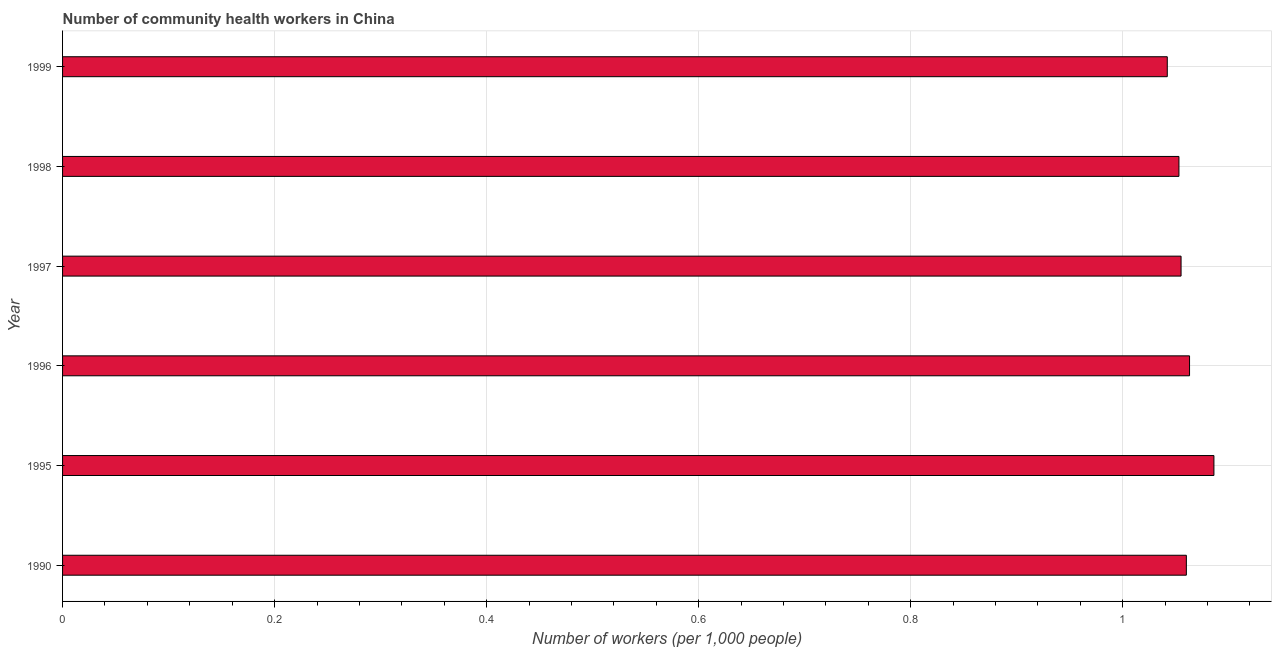Does the graph contain grids?
Your answer should be very brief. Yes. What is the title of the graph?
Your answer should be compact. Number of community health workers in China. What is the label or title of the X-axis?
Provide a succinct answer. Number of workers (per 1,0 people). What is the number of community health workers in 1998?
Provide a short and direct response. 1.05. Across all years, what is the maximum number of community health workers?
Provide a short and direct response. 1.09. Across all years, what is the minimum number of community health workers?
Ensure brevity in your answer.  1.04. In which year was the number of community health workers maximum?
Offer a terse response. 1995. What is the sum of the number of community health workers?
Provide a short and direct response. 6.36. What is the difference between the number of community health workers in 1990 and 1995?
Offer a terse response. -0.03. What is the average number of community health workers per year?
Offer a very short reply. 1.06. What is the median number of community health workers?
Provide a short and direct response. 1.06. Do a majority of the years between 1995 and 1997 (inclusive) have number of community health workers greater than 0.64 ?
Give a very brief answer. Yes. What is the difference between the highest and the second highest number of community health workers?
Provide a short and direct response. 0.02. What is the difference between the highest and the lowest number of community health workers?
Your answer should be compact. 0.04. How many bars are there?
Make the answer very short. 6. Are all the bars in the graph horizontal?
Make the answer very short. Yes. How many years are there in the graph?
Make the answer very short. 6. What is the difference between two consecutive major ticks on the X-axis?
Your answer should be very brief. 0.2. Are the values on the major ticks of X-axis written in scientific E-notation?
Provide a short and direct response. No. What is the Number of workers (per 1,000 people) of 1990?
Keep it short and to the point. 1.06. What is the Number of workers (per 1,000 people) of 1995?
Make the answer very short. 1.09. What is the Number of workers (per 1,000 people) of 1996?
Ensure brevity in your answer.  1.06. What is the Number of workers (per 1,000 people) in 1997?
Offer a very short reply. 1.05. What is the Number of workers (per 1,000 people) in 1998?
Provide a short and direct response. 1.05. What is the Number of workers (per 1,000 people) of 1999?
Offer a very short reply. 1.04. What is the difference between the Number of workers (per 1,000 people) in 1990 and 1995?
Your response must be concise. -0.03. What is the difference between the Number of workers (per 1,000 people) in 1990 and 1996?
Offer a terse response. -0. What is the difference between the Number of workers (per 1,000 people) in 1990 and 1997?
Offer a terse response. 0.01. What is the difference between the Number of workers (per 1,000 people) in 1990 and 1998?
Your answer should be very brief. 0.01. What is the difference between the Number of workers (per 1,000 people) in 1990 and 1999?
Keep it short and to the point. 0.02. What is the difference between the Number of workers (per 1,000 people) in 1995 and 1996?
Provide a short and direct response. 0.02. What is the difference between the Number of workers (per 1,000 people) in 1995 and 1997?
Offer a terse response. 0.03. What is the difference between the Number of workers (per 1,000 people) in 1995 and 1998?
Give a very brief answer. 0.03. What is the difference between the Number of workers (per 1,000 people) in 1995 and 1999?
Offer a very short reply. 0.04. What is the difference between the Number of workers (per 1,000 people) in 1996 and 1997?
Offer a very short reply. 0.01. What is the difference between the Number of workers (per 1,000 people) in 1996 and 1999?
Keep it short and to the point. 0.02. What is the difference between the Number of workers (per 1,000 people) in 1997 and 1998?
Provide a short and direct response. 0. What is the difference between the Number of workers (per 1,000 people) in 1997 and 1999?
Offer a terse response. 0.01. What is the difference between the Number of workers (per 1,000 people) in 1998 and 1999?
Keep it short and to the point. 0.01. What is the ratio of the Number of workers (per 1,000 people) in 1995 to that in 1998?
Your response must be concise. 1.03. What is the ratio of the Number of workers (per 1,000 people) in 1995 to that in 1999?
Provide a succinct answer. 1.04. What is the ratio of the Number of workers (per 1,000 people) in 1996 to that in 1997?
Provide a succinct answer. 1.01. What is the ratio of the Number of workers (per 1,000 people) in 1997 to that in 1999?
Keep it short and to the point. 1.01. What is the ratio of the Number of workers (per 1,000 people) in 1998 to that in 1999?
Your answer should be compact. 1.01. 